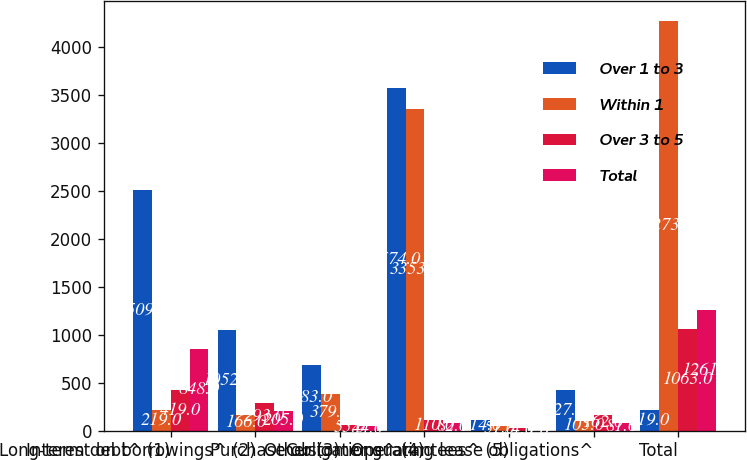Convert chart. <chart><loc_0><loc_0><loc_500><loc_500><stacked_bar_chart><ecel><fcel>Long-term debt^ (1)<fcel>Interest on borrowings^ (2)<fcel>Other (3)<fcel>Purchase obligations^ (4)<fcel>Customer guarantees^ (5)<fcel>Operating lease obligations^<fcel>Total<nl><fcel>Over 1 to 3<fcel>2509<fcel>1052<fcel>683<fcel>3574<fcel>114<fcel>427<fcel>219<nl><fcel>Within 1<fcel>219<fcel>166<fcel>379<fcel>3353<fcel>51<fcel>105<fcel>4273<nl><fcel>Over 3 to 5<fcel>419<fcel>293<fcel>55<fcel>110<fcel>24<fcel>162<fcel>1063<nl><fcel>Total<fcel>848<fcel>205<fcel>44<fcel>82<fcel>1<fcel>81<fcel>1261<nl></chart> 